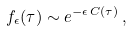Convert formula to latex. <formula><loc_0><loc_0><loc_500><loc_500>f _ { \epsilon } ( \tau ) \sim e ^ { - \epsilon \, C ( \tau ) } \, ,</formula> 